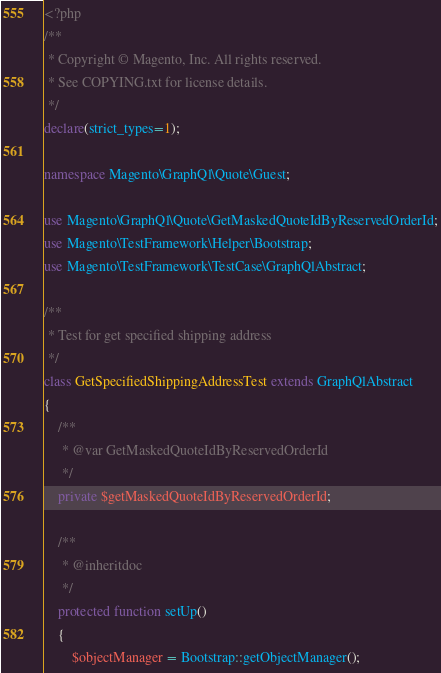Convert code to text. <code><loc_0><loc_0><loc_500><loc_500><_PHP_><?php
/**
 * Copyright © Magento, Inc. All rights reserved.
 * See COPYING.txt for license details.
 */
declare(strict_types=1);

namespace Magento\GraphQl\Quote\Guest;

use Magento\GraphQl\Quote\GetMaskedQuoteIdByReservedOrderId;
use Magento\TestFramework\Helper\Bootstrap;
use Magento\TestFramework\TestCase\GraphQlAbstract;

/**
 * Test for get specified shipping address
 */
class GetSpecifiedShippingAddressTest extends GraphQlAbstract
{
    /**
     * @var GetMaskedQuoteIdByReservedOrderId
     */
    private $getMaskedQuoteIdByReservedOrderId;

    /**
     * @inheritdoc
     */
    protected function setUp()
    {
        $objectManager = Bootstrap::getObjectManager();</code> 